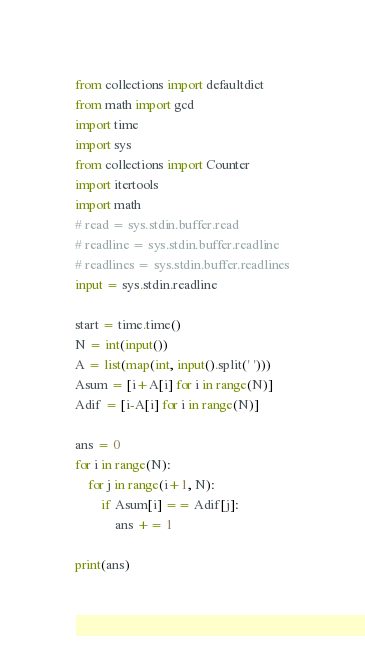<code> <loc_0><loc_0><loc_500><loc_500><_Python_>from collections import defaultdict
from math import gcd
import time
import sys
from collections import Counter
import itertools
import math
# read = sys.stdin.buffer.read
# readline = sys.stdin.buffer.readline
# readlines = sys.stdin.buffer.readlines
input = sys.stdin.readline

start = time.time()
N = int(input())
A = list(map(int, input().split(' ')))
Asum = [i+A[i] for i in range(N)]
Adif = [i-A[i] for i in range(N)]

ans = 0
for i in range(N):
    for j in range(i+1, N):
        if Asum[i] == Adif[j]:
            ans += 1

print(ans)
</code> 